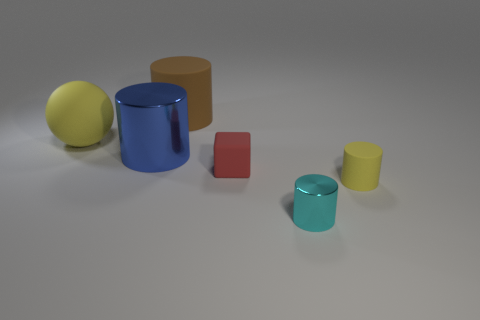Add 3 purple blocks. How many objects exist? 9 Subtract all spheres. How many objects are left? 5 Add 2 brown rubber cylinders. How many brown rubber cylinders exist? 3 Subtract 0 green blocks. How many objects are left? 6 Subtract all tiny metal cylinders. Subtract all big metal cylinders. How many objects are left? 4 Add 1 red objects. How many red objects are left? 2 